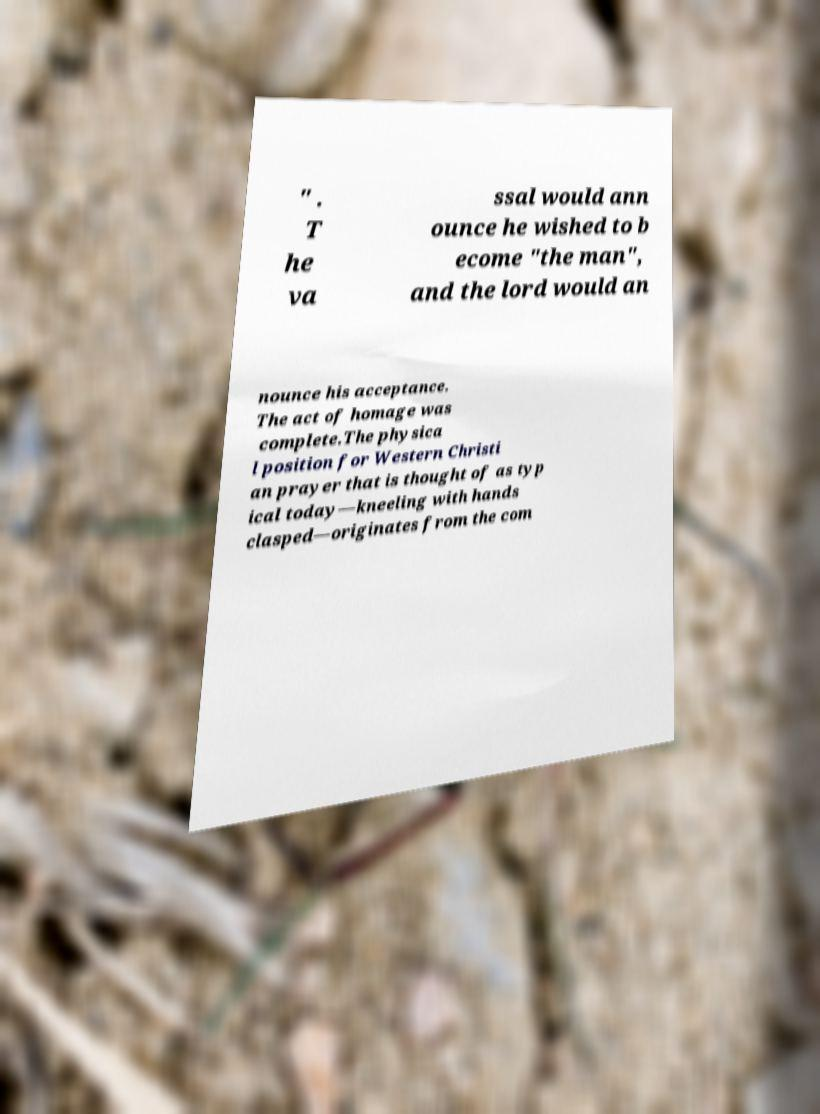What messages or text are displayed in this image? I need them in a readable, typed format. " . T he va ssal would ann ounce he wished to b ecome "the man", and the lord would an nounce his acceptance. The act of homage was complete.The physica l position for Western Christi an prayer that is thought of as typ ical today—kneeling with hands clasped—originates from the com 